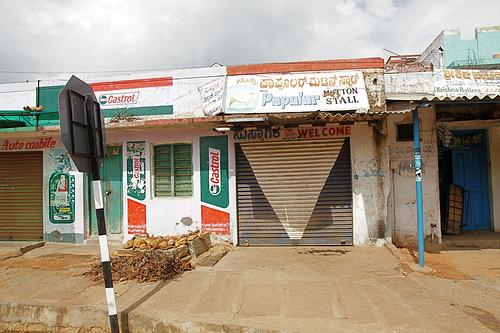Is this building new?
Give a very brief answer. No. What oil brand is on the building that is white, orange and green?
Concise answer only. Castrol. Where is the welcome sign?
Answer briefly. On door. 